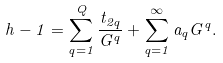<formula> <loc_0><loc_0><loc_500><loc_500>h - 1 = \sum _ { q = 1 } ^ { Q } { \frac { t _ { 2 q } } { G ^ { q } } } + \sum _ { q = 1 } ^ { \infty } a _ { q } G ^ { q } .</formula> 